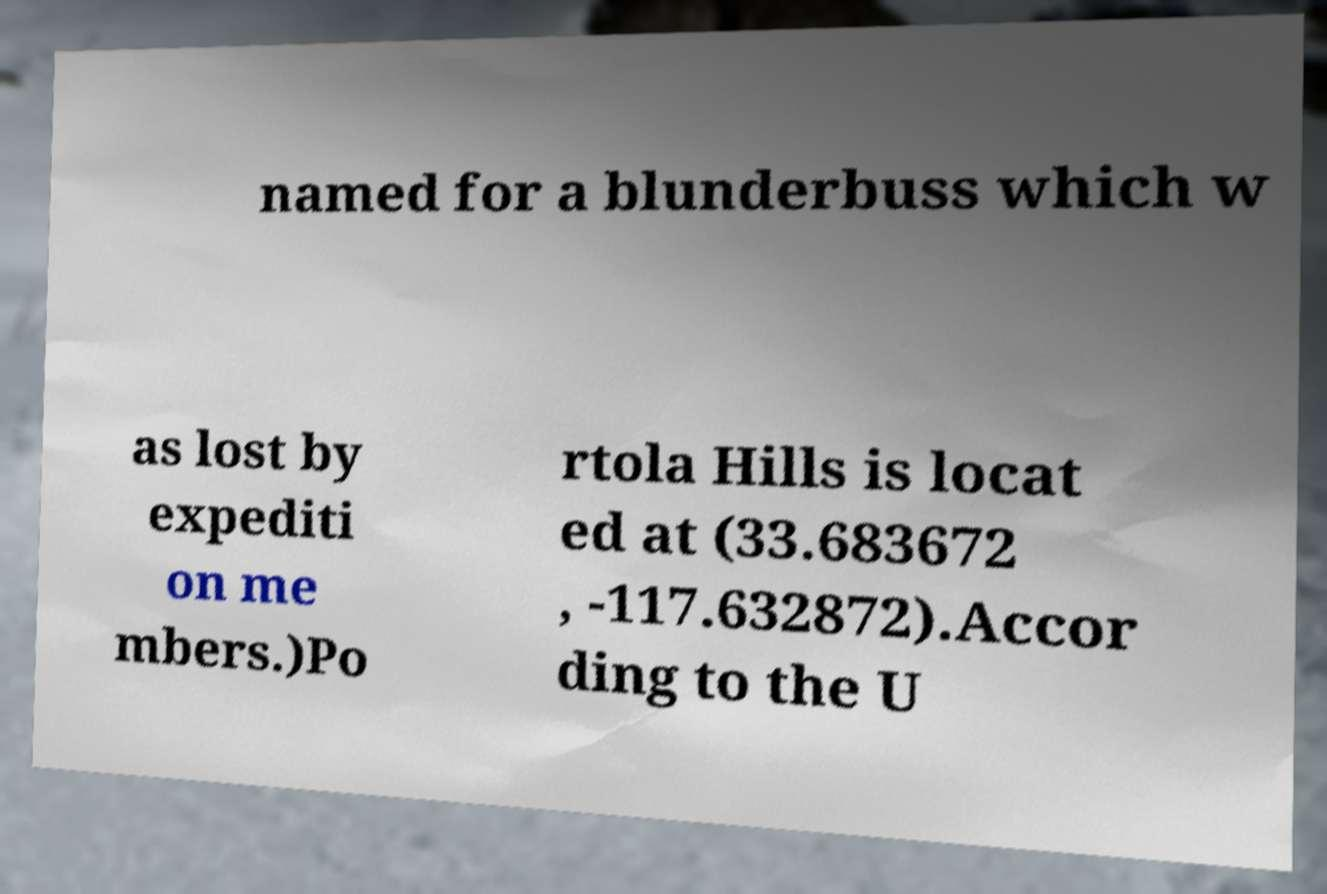For documentation purposes, I need the text within this image transcribed. Could you provide that? named for a blunderbuss which w as lost by expediti on me mbers.)Po rtola Hills is locat ed at (33.683672 , -117.632872).Accor ding to the U 